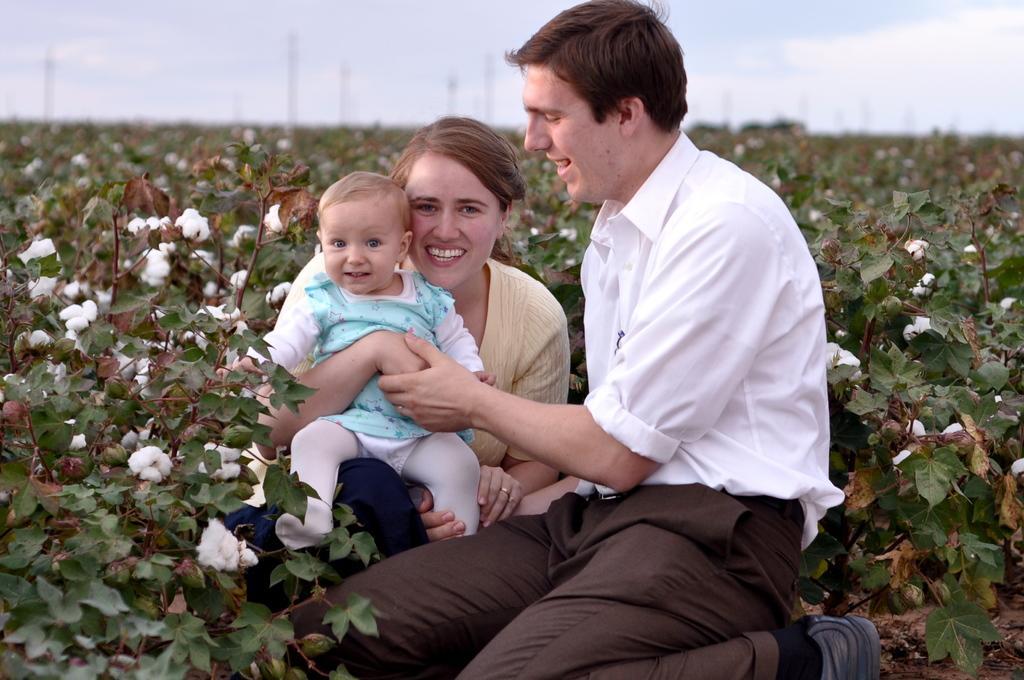Can you describe this image briefly? There is a man and a woman holding a baby. Near to them there are cotton plants. 